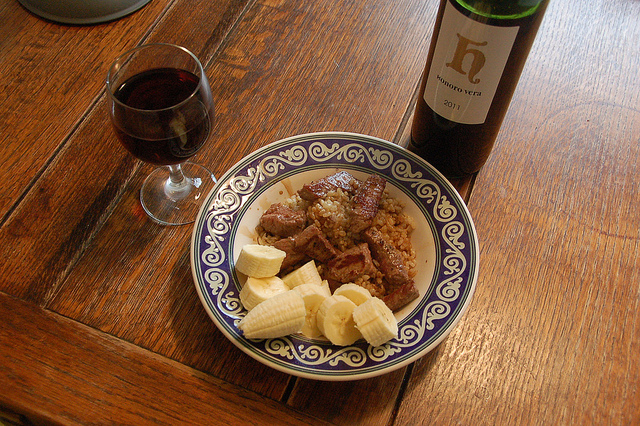Identify and read out the text in this image. H 